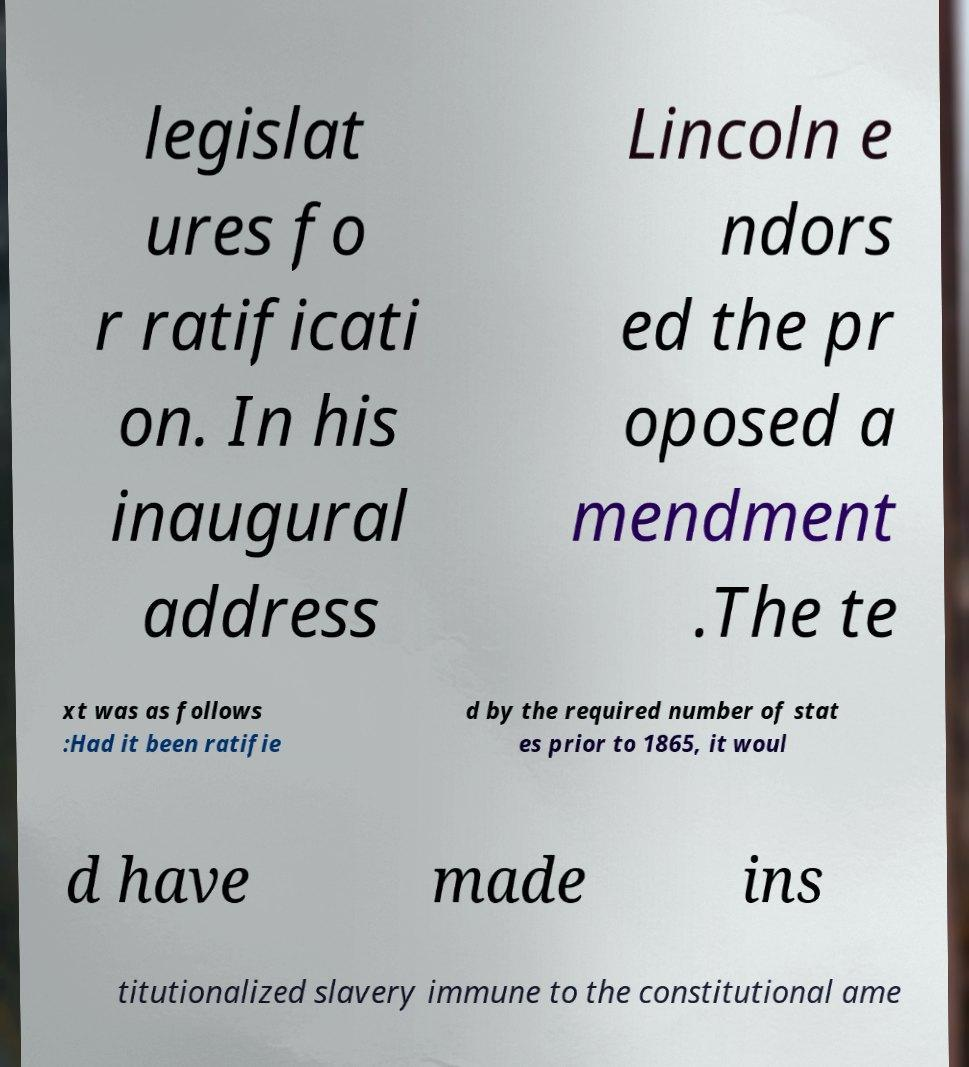Can you accurately transcribe the text from the provided image for me? legislat ures fo r ratificati on. In his inaugural address Lincoln e ndors ed the pr oposed a mendment .The te xt was as follows :Had it been ratifie d by the required number of stat es prior to 1865, it woul d have made ins titutionalized slavery immune to the constitutional ame 